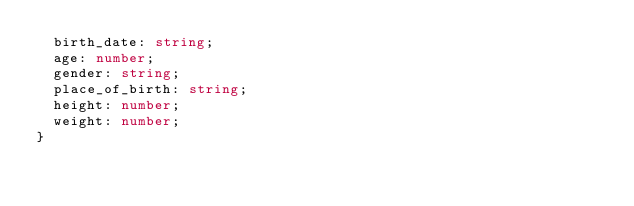<code> <loc_0><loc_0><loc_500><loc_500><_TypeScript_>  birth_date: string;
  age: number;
  gender: string;
  place_of_birth: string;
  height: number;
  weight: number;
}
</code> 